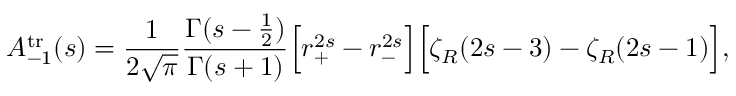<formula> <loc_0><loc_0><loc_500><loc_500>A _ { - 1 } ^ { t r } ( s ) = { \frac { 1 } { 2 \sqrt { \pi } } } { \frac { \Gamma ( s - { \frac { 1 } { 2 } } ) } { \Gamma ( s + 1 ) } } \left [ r _ { + } ^ { 2 s } - r _ { - } ^ { 2 s } \right ] \left [ \zeta _ { R } ( 2 s - 3 ) - \zeta _ { R } ( 2 s - 1 ) \right ] ,</formula> 